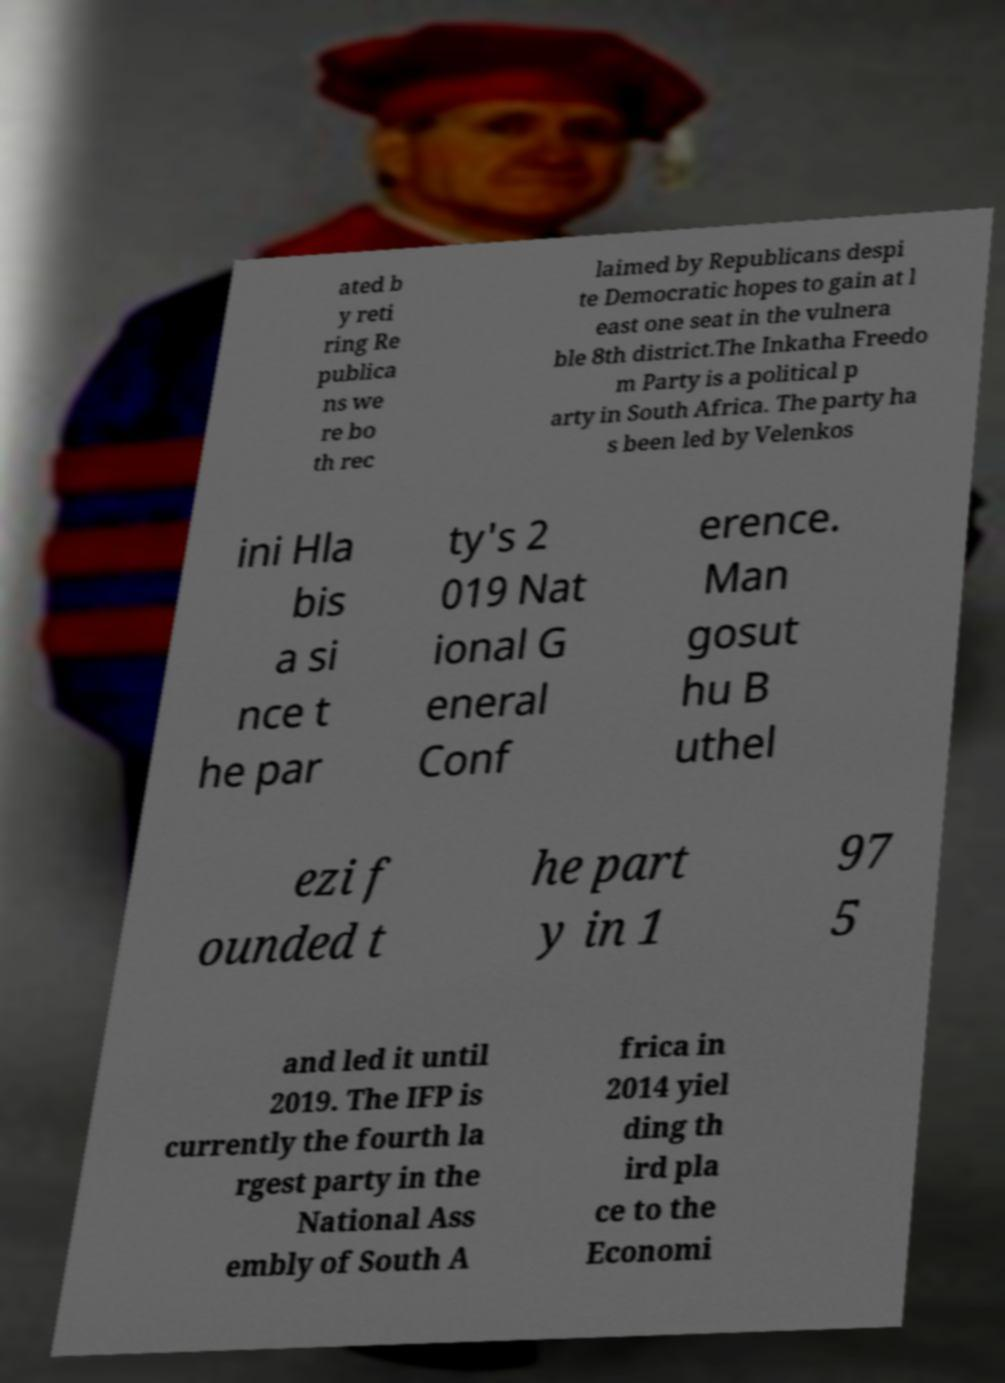For documentation purposes, I need the text within this image transcribed. Could you provide that? ated b y reti ring Re publica ns we re bo th rec laimed by Republicans despi te Democratic hopes to gain at l east one seat in the vulnera ble 8th district.The Inkatha Freedo m Party is a political p arty in South Africa. The party ha s been led by Velenkos ini Hla bis a si nce t he par ty's 2 019 Nat ional G eneral Conf erence. Man gosut hu B uthel ezi f ounded t he part y in 1 97 5 and led it until 2019. The IFP is currently the fourth la rgest party in the National Ass embly of South A frica in 2014 yiel ding th ird pla ce to the Economi 